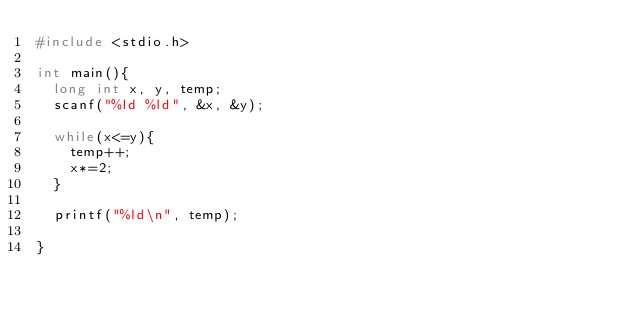<code> <loc_0><loc_0><loc_500><loc_500><_C_>#include <stdio.h>

int main(){
  long int x, y, temp;
  scanf("%ld %ld", &x, &y);

  while(x<=y){
    temp++;
    x*=2;
  }

  printf("%ld\n", temp);

}</code> 